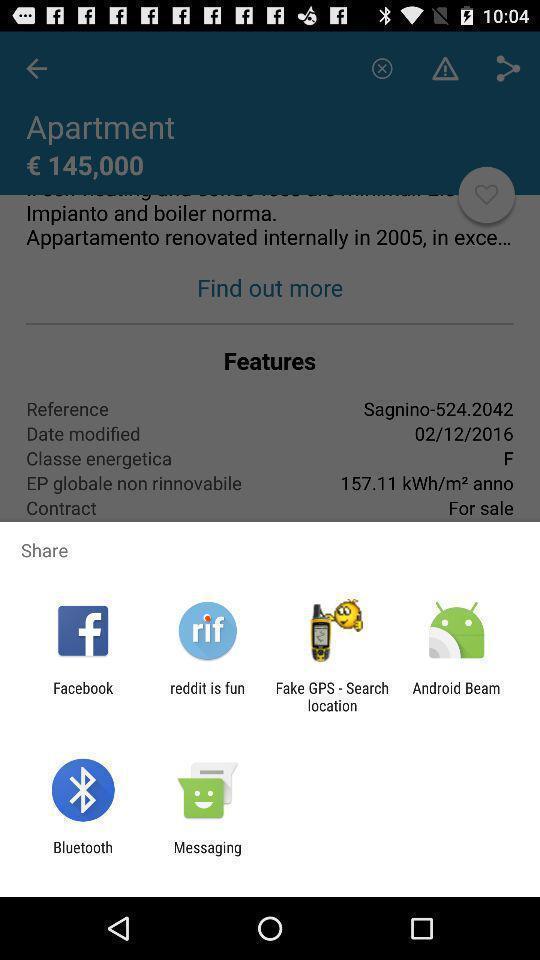What is the overall content of this screenshot? Pop-up displaying different applications to share. 